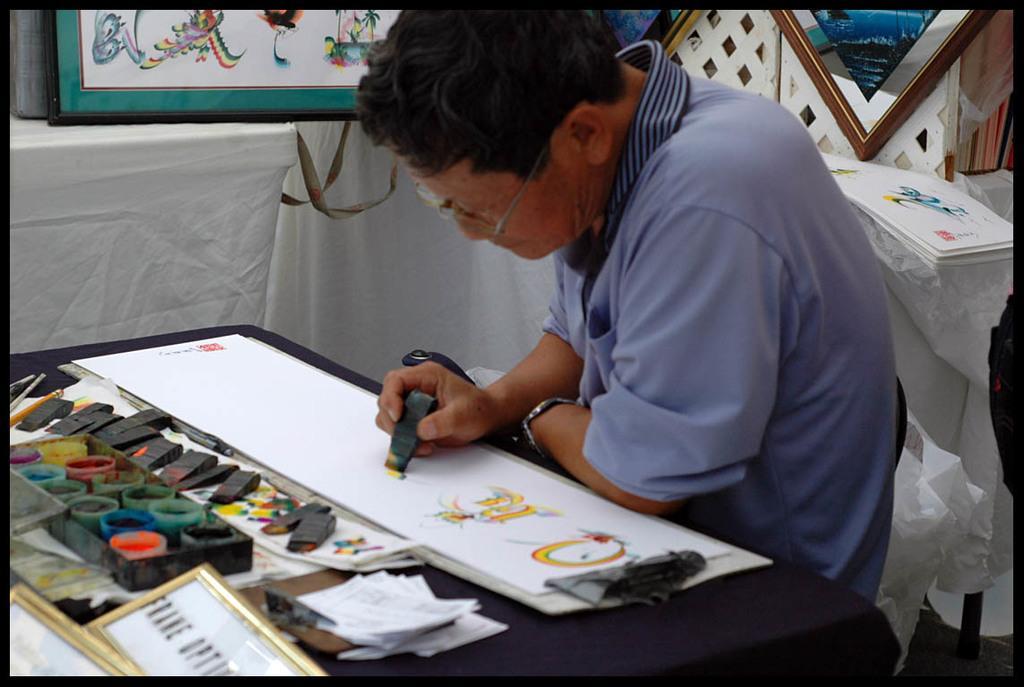Could you give a brief overview of what you see in this image? This picture shows a man seated on the chair and painting on the paper with the brush and we see colors box and few papers on the table and we see few frames and few papers on the side and men wore spectacles on his face. 